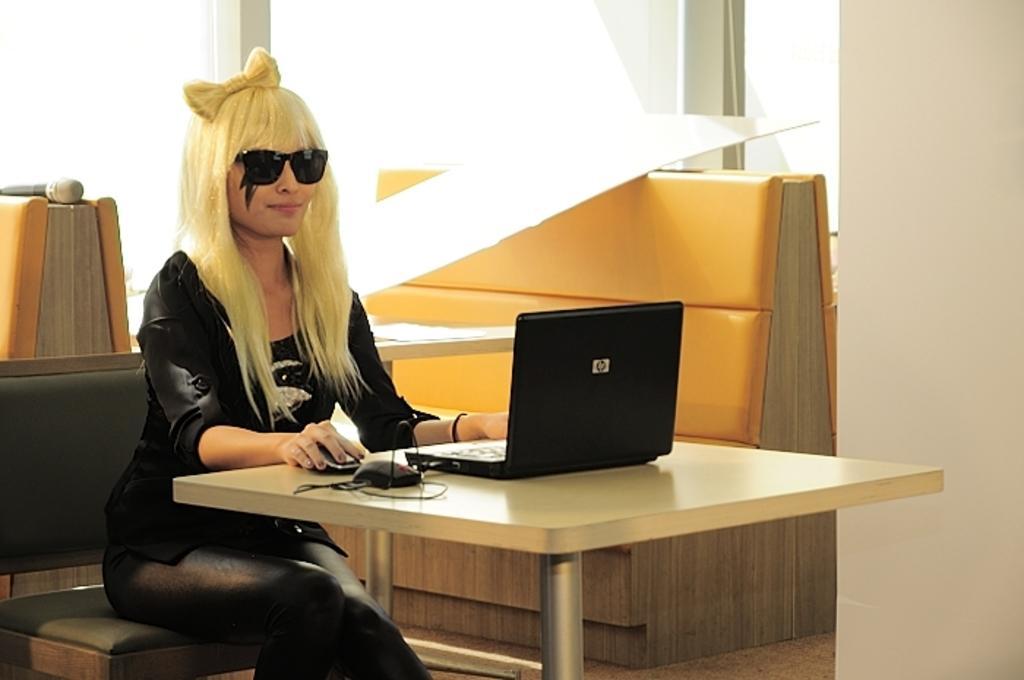How would you summarize this image in a sentence or two? A woman is sitting in the chair and working in the laptop she wear a black color dress. 